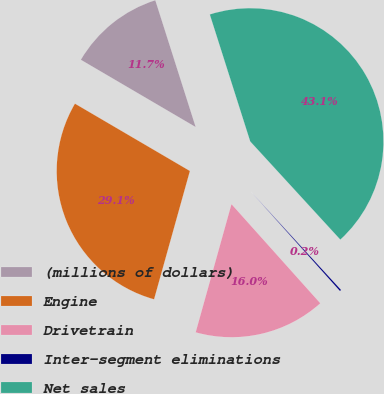Convert chart to OTSL. <chart><loc_0><loc_0><loc_500><loc_500><pie_chart><fcel>(millions of dollars)<fcel>Engine<fcel>Drivetrain<fcel>Inter-segment eliminations<fcel>Net sales<nl><fcel>11.66%<fcel>29.1%<fcel>15.96%<fcel>0.19%<fcel>43.09%<nl></chart> 